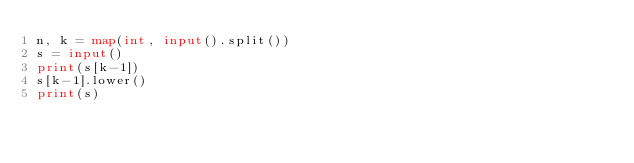Convert code to text. <code><loc_0><loc_0><loc_500><loc_500><_Python_>n, k = map(int, input().split())
s = input()
print(s[k-1])
s[k-1].lower()
print(s)</code> 